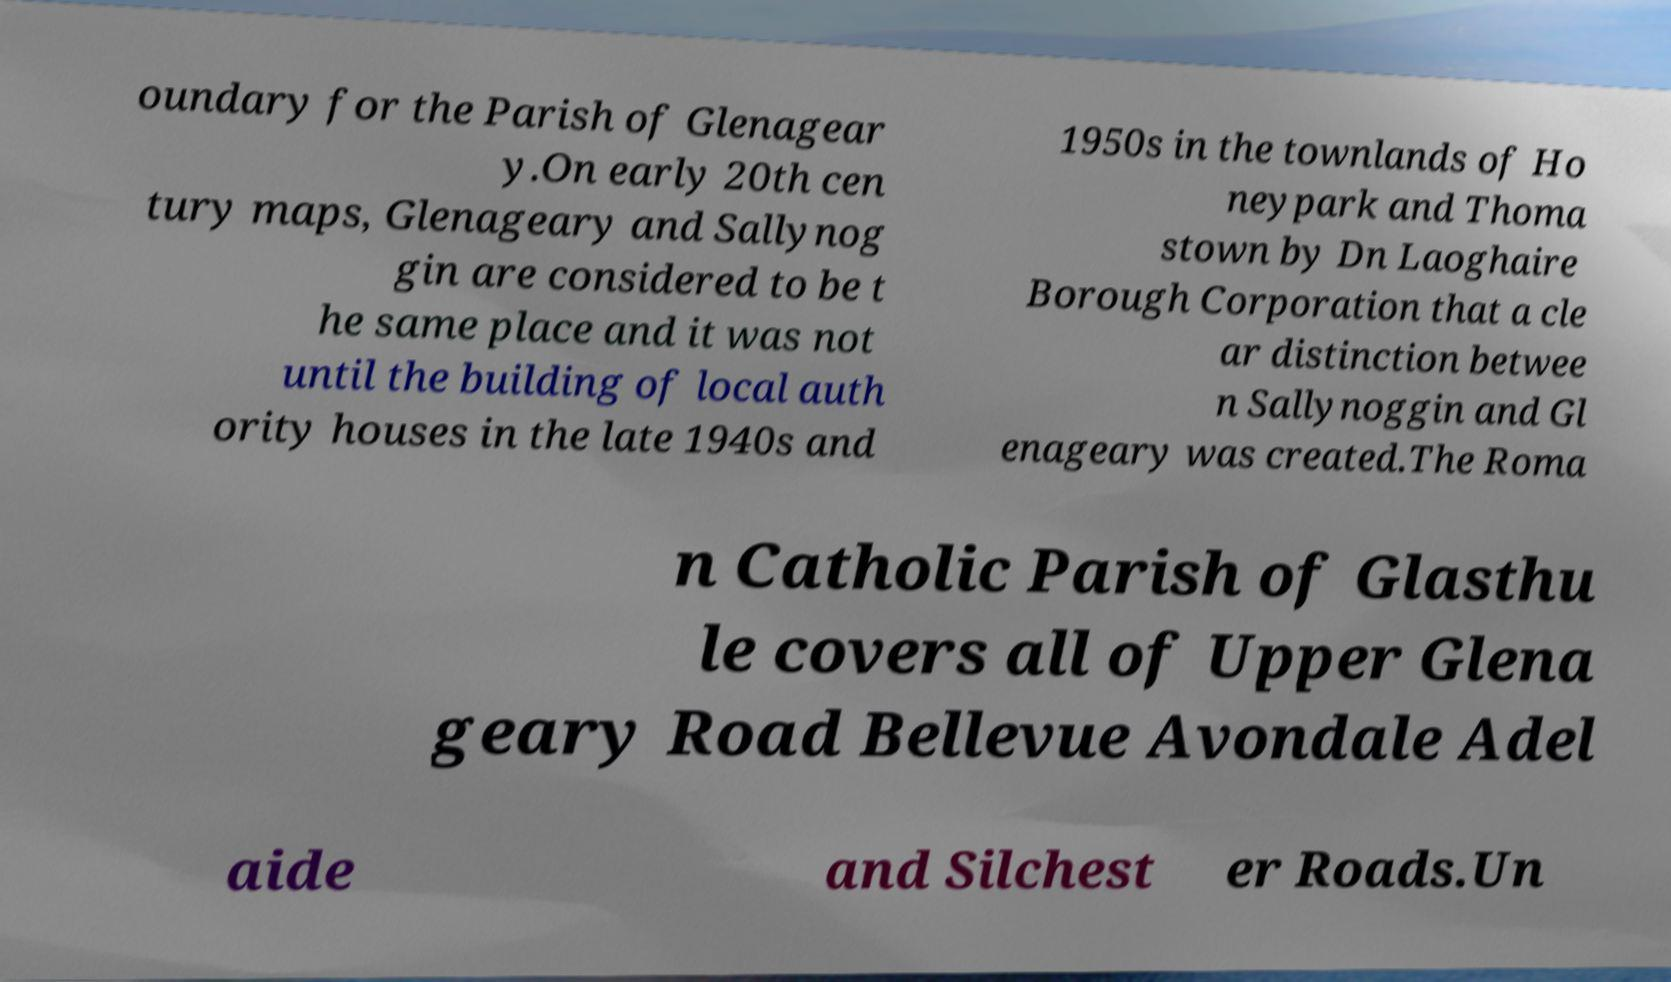There's text embedded in this image that I need extracted. Can you transcribe it verbatim? oundary for the Parish of Glenagear y.On early 20th cen tury maps, Glenageary and Sallynog gin are considered to be t he same place and it was not until the building of local auth ority houses in the late 1940s and 1950s in the townlands of Ho neypark and Thoma stown by Dn Laoghaire Borough Corporation that a cle ar distinction betwee n Sallynoggin and Gl enageary was created.The Roma n Catholic Parish of Glasthu le covers all of Upper Glena geary Road Bellevue Avondale Adel aide and Silchest er Roads.Un 